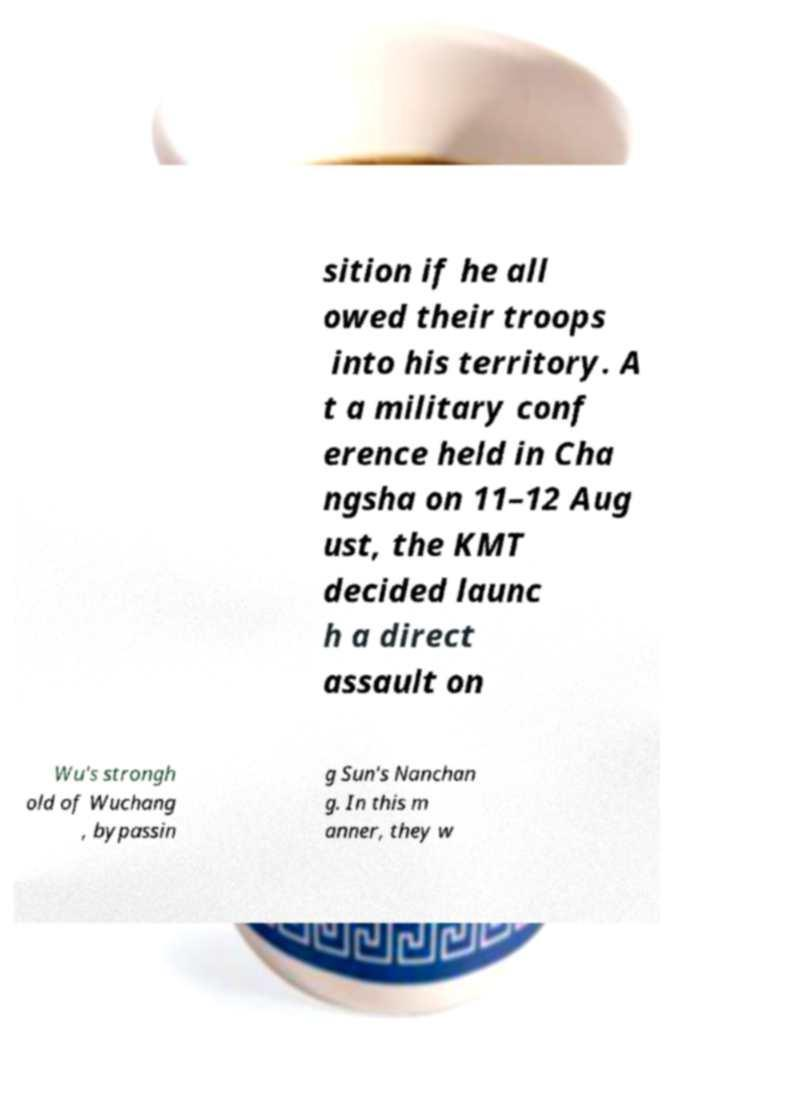What messages or text are displayed in this image? I need them in a readable, typed format. sition if he all owed their troops into his territory. A t a military conf erence held in Cha ngsha on 11–12 Aug ust, the KMT decided launc h a direct assault on Wu's strongh old of Wuchang , bypassin g Sun's Nanchan g. In this m anner, they w 